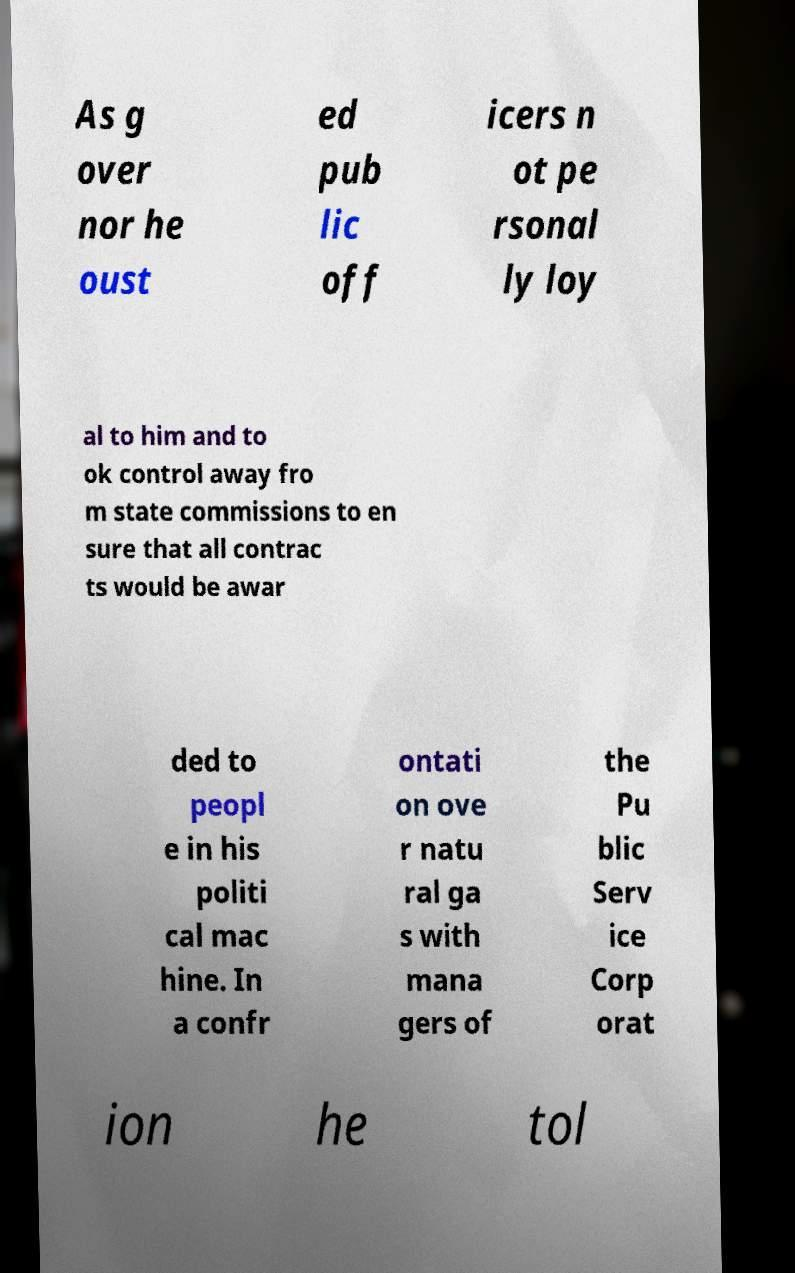I need the written content from this picture converted into text. Can you do that? As g over nor he oust ed pub lic off icers n ot pe rsonal ly loy al to him and to ok control away fro m state commissions to en sure that all contrac ts would be awar ded to peopl e in his politi cal mac hine. In a confr ontati on ove r natu ral ga s with mana gers of the Pu blic Serv ice Corp orat ion he tol 